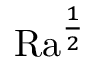<formula> <loc_0><loc_0><loc_500><loc_500>{ R a } ^ { \frac { 1 } { 2 } }</formula> 